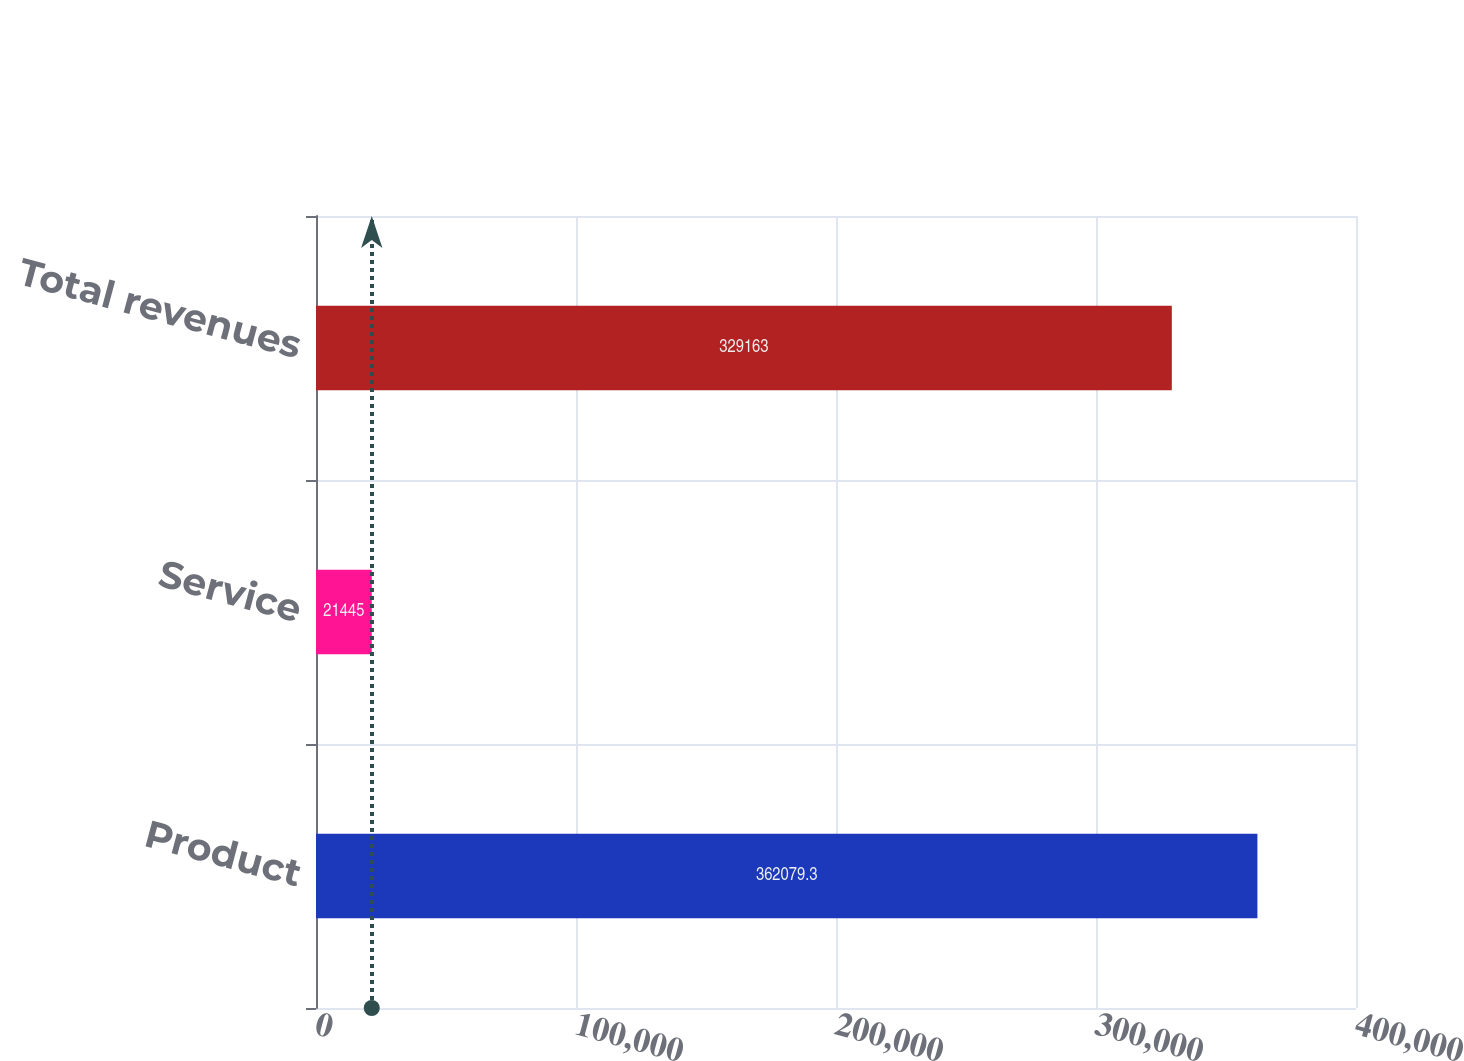Convert chart. <chart><loc_0><loc_0><loc_500><loc_500><bar_chart><fcel>Product<fcel>Service<fcel>Total revenues<nl><fcel>362079<fcel>21445<fcel>329163<nl></chart> 